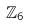Convert formula to latex. <formula><loc_0><loc_0><loc_500><loc_500>\mathbb { Z } _ { 6 }</formula> 